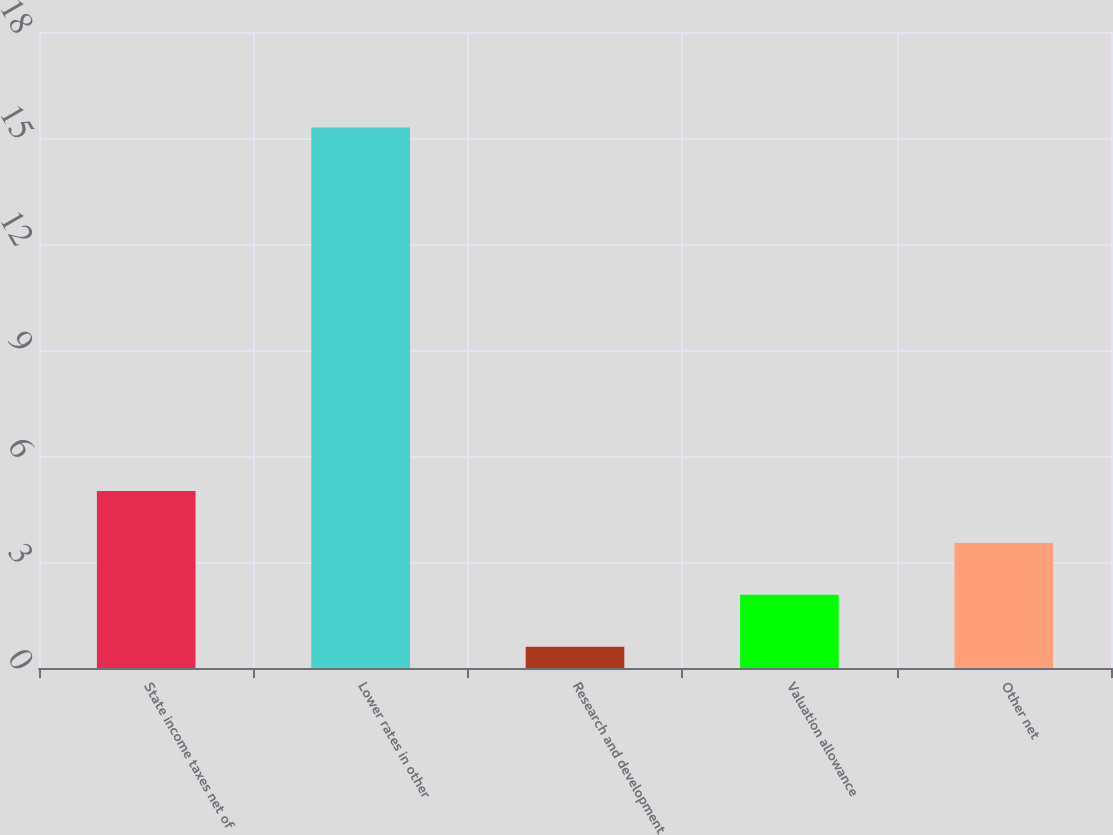<chart> <loc_0><loc_0><loc_500><loc_500><bar_chart><fcel>State income taxes net of<fcel>Lower rates in other<fcel>Research and development<fcel>Valuation allowance<fcel>Other net<nl><fcel>5.01<fcel>15.3<fcel>0.6<fcel>2.07<fcel>3.54<nl></chart> 